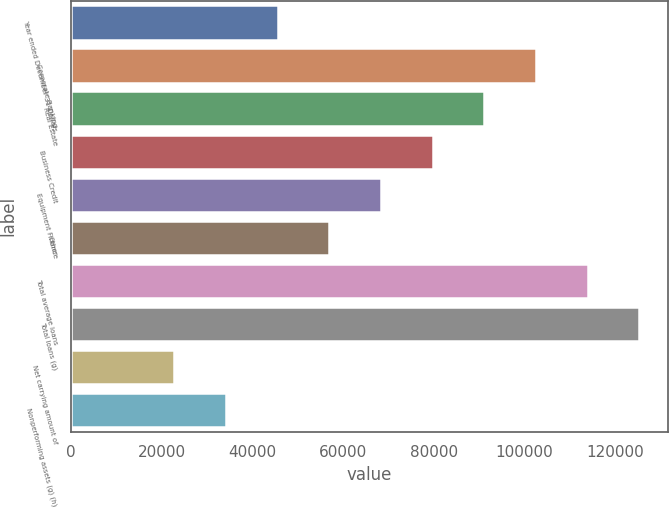Convert chart. <chart><loc_0><loc_0><loc_500><loc_500><bar_chart><fcel>Year ended December 31 Dollars<fcel>Corporate Banking<fcel>Real Estate<fcel>Business Credit<fcel>Equipment Finance<fcel>Other<fcel>Total average loans<fcel>Total loans (g)<fcel>Net carrying amount of<fcel>Nonperforming assets (g) (h)<nl><fcel>45578.8<fcel>102542<fcel>91149.6<fcel>79756.9<fcel>68364.2<fcel>56971.5<fcel>113935<fcel>125328<fcel>22793.4<fcel>34186.1<nl></chart> 